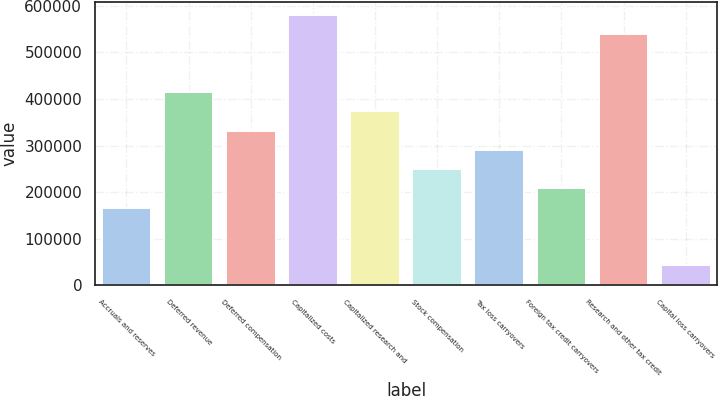Convert chart to OTSL. <chart><loc_0><loc_0><loc_500><loc_500><bar_chart><fcel>Accruals and reserves<fcel>Deferred revenue<fcel>Deferred compensation<fcel>Capitalized costs<fcel>Capitalized research and<fcel>Stock compensation<fcel>Tax loss carryovers<fcel>Foreign tax credit carryovers<fcel>Research and other tax credit<fcel>Capital loss carryovers<nl><fcel>166728<fcel>414797<fcel>332107<fcel>580176<fcel>373452<fcel>249418<fcel>290763<fcel>208073<fcel>538831<fcel>42693.8<nl></chart> 